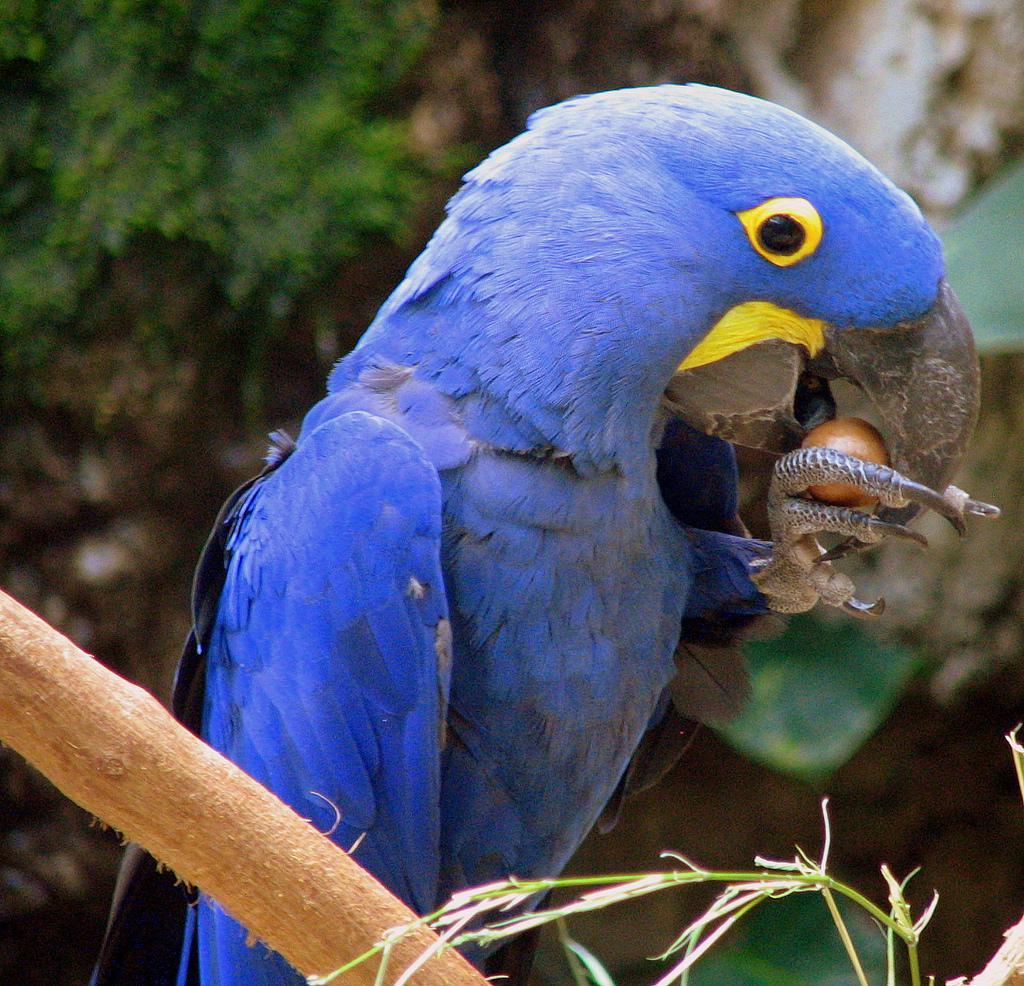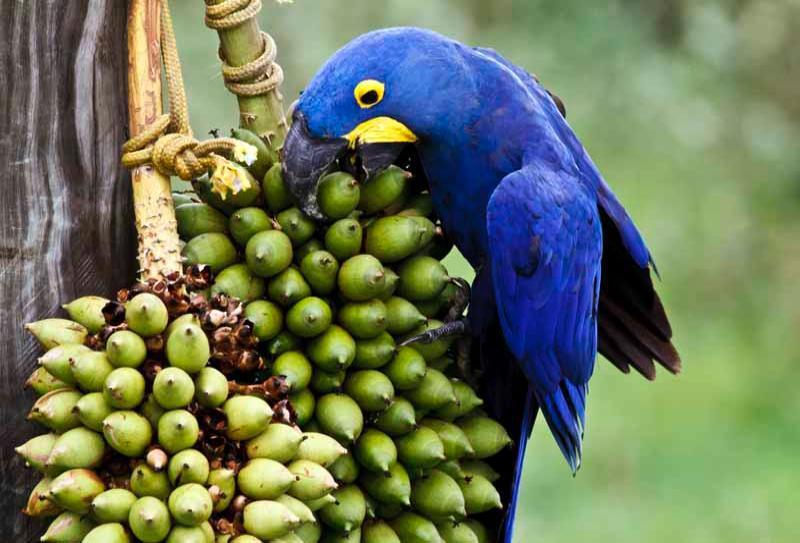The first image is the image on the left, the second image is the image on the right. Given the left and right images, does the statement "There are three parrots." hold true? Answer yes or no. No. 